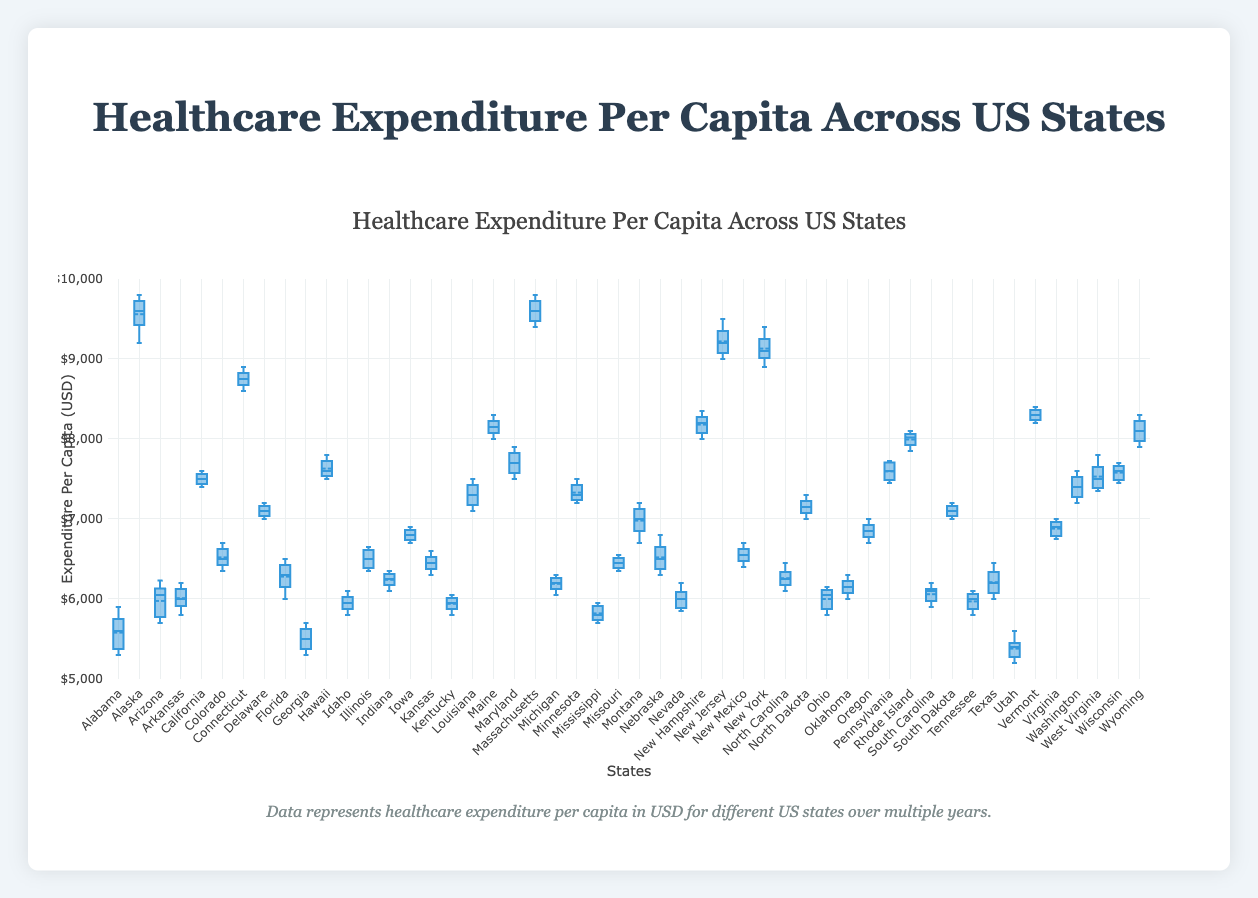What's the title of the figure? The title is usually located at the top of the figure and describes the overall content. The title of the figure is "Healthcare Expenditure Per Capita Across US States".
Answer: Healthcare Expenditure Per Capita Across US States What does the y-axis represent? The y-axis label shows what is being measured on the vertical axis. It represents "Expenditure Per Capita (USD)".
Answer: Expenditure Per Capita (USD) Which state has the highest median healthcare expenditure per capita? By examining the central lines in each box, Massachusetts has the highest median healthcare expenditure per capita.
Answer: Massachusetts Among Alaska, California, and Connecticut, which state has the lowest healthcare expenditure range? The range can be determined by the distance between the whiskers (min and max). California has the lowest range among the three.
Answer: California By looking at the plot, which state has the least variability in healthcare expenditure per capita? Variability is seen in the width of the interquartile range (IQR), marked by the box. Utah has the smallest box, indicating the least variability.
Answer: Utah Which state has the maximum outlier values beyond the whiskers? Outliers are indicated by individual points beyond the whiskers. Alaska has outliers above the whiskers more frequently than other states.
Answer: Alaska Compare the median healthcare expenses of Texas and Florida. Which state has higher median expenses? The median value is the line within the box. Texas has a median roughly at $6200, while Florida’s is slightly lower at $6150.
Answer: Texas What is the approximate interquartile range (IQR) for Massachusetts? The IQR is the range of the middle 50% of the data, from the first quartile (Q1) to the third quartile (Q3). For Massachusetts, Q1 is around $9500 USD and Q3 is around $9650 USD. Therefore, the IQR is about $150 USD.
Answer: $150 Identify the state with the median healthcare expenditure closest to the overall median value observed in the plot. The overall median line (or general center if provided) can be matched against each state's median line. North Carolina’s median is very close to the overall median.
Answer: North Carolina Which state has the maximum median healthcare expenditure among the following: Oregon, Kansas, and Nebraska? The median line within the box needs to be compared. Oregon's median is approximately $6900 while Kansas ($6450) and Nebraska ($6500) are lower.
Answer: Oregon 